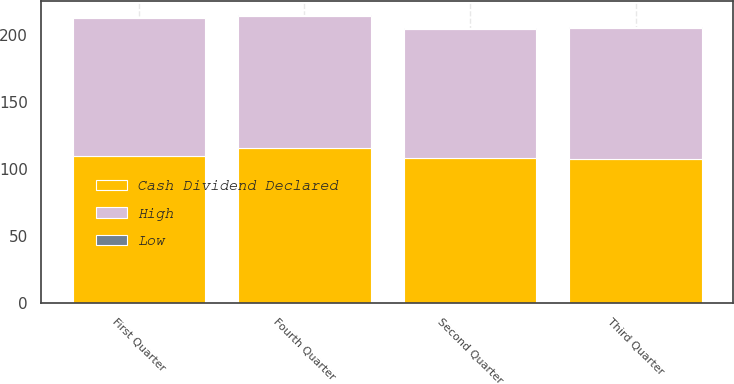<chart> <loc_0><loc_0><loc_500><loc_500><stacked_bar_chart><ecel><fcel>First Quarter<fcel>Second Quarter<fcel>Third Quarter<fcel>Fourth Quarter<nl><fcel>Cash Dividend Declared<fcel>109.73<fcel>108.67<fcel>107.82<fcel>115.83<nl><fcel>High<fcel>102.82<fcel>96.14<fcel>97.49<fcel>98.34<nl><fcel>Low<fcel>0.55<fcel>0.61<fcel>0.61<fcel>0.61<nl></chart> 